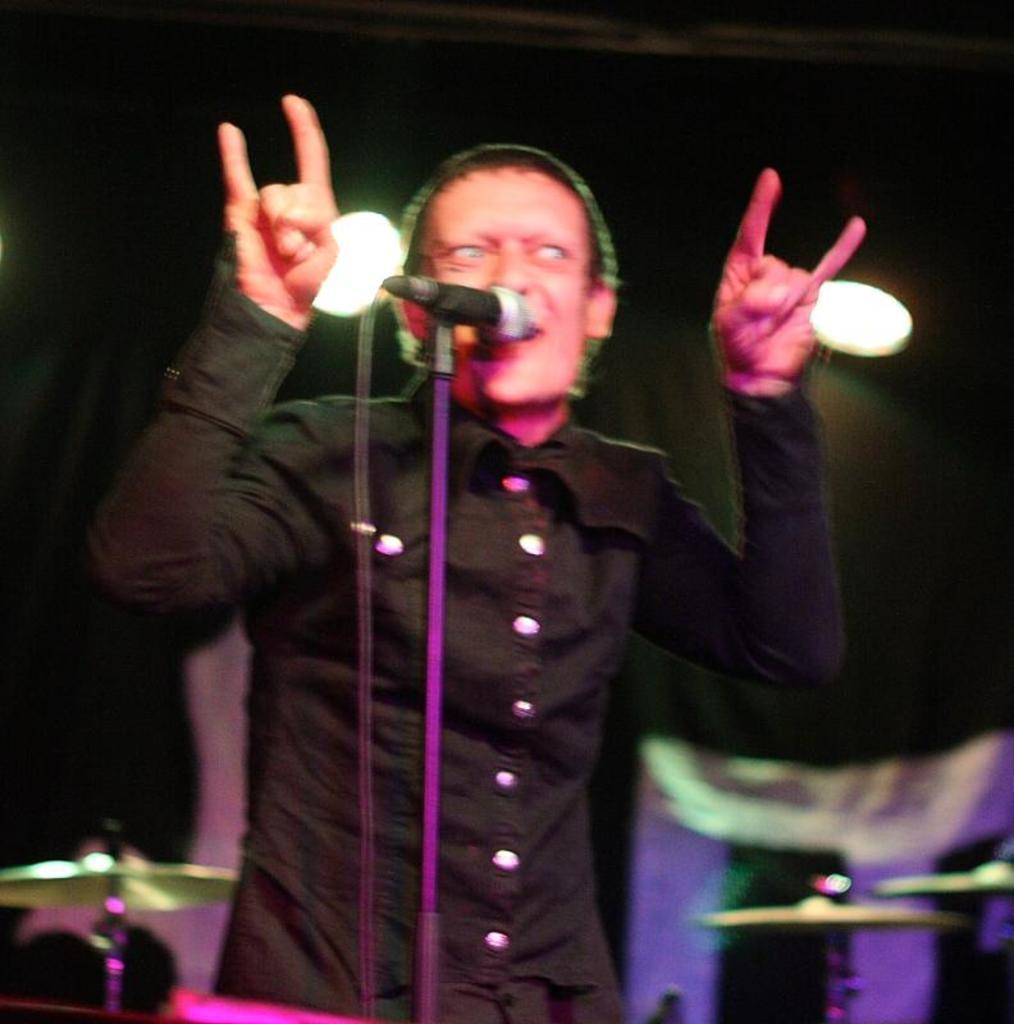How would you summarize this image in a sentence or two? In this image a man is standing in front of the mic and is giving some expressions raising his hands. In the background there are some musical instruments and spotlights. 